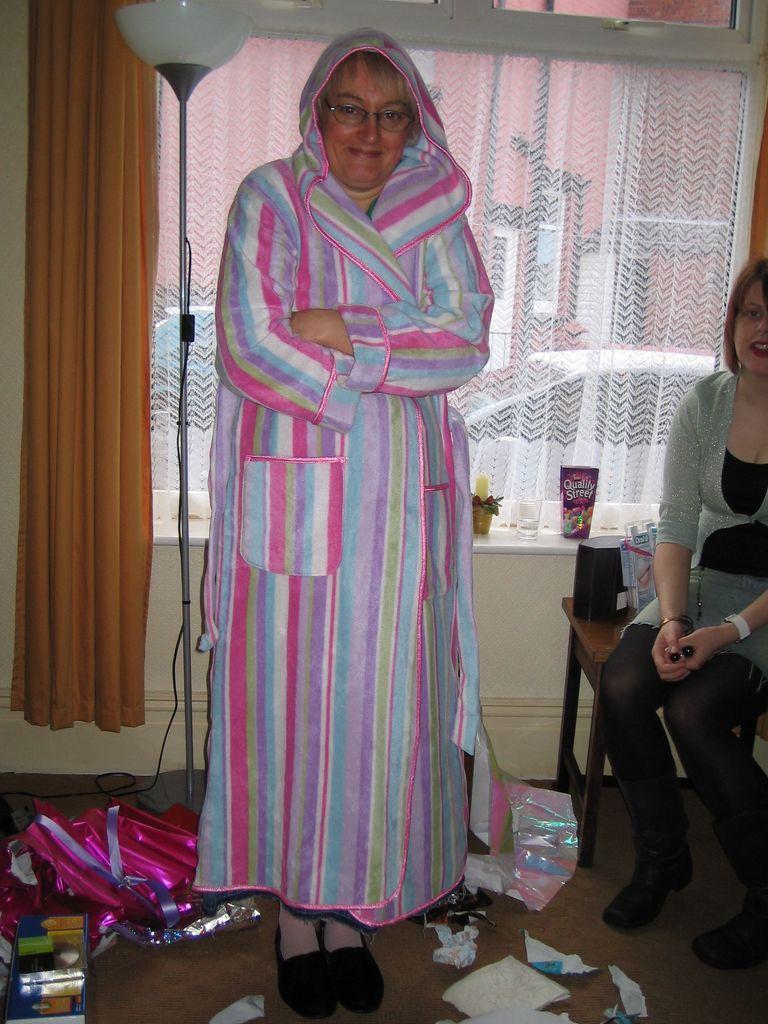In one or two sentences, can you explain what this image depicts? This picture is clicked inside the room. The woman in the middle of the picture wearing a pink and violet dress is standing and she is smiling. Beside her, we see a woman in grey and black dress is sitting on the chair. Beside her, we see a table on which black color object is placed. Beside that, we see a glass and a pink color object. Behind her, we see a lamp, a yellow curtain and a window from which we can see buildings and cars. At the bottom of the picture, we see papers and some decorative items. 